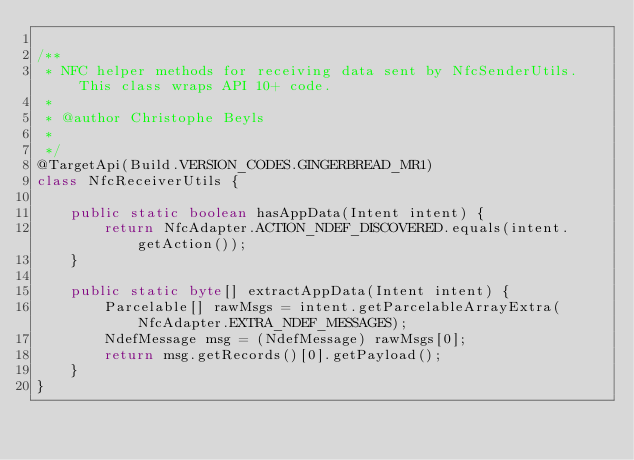<code> <loc_0><loc_0><loc_500><loc_500><_Java_>
/**
 * NFC helper methods for receiving data sent by NfcSenderUtils. This class wraps API 10+ code.
 * 
 * @author Christophe Beyls
 * 
 */
@TargetApi(Build.VERSION_CODES.GINGERBREAD_MR1)
class NfcReceiverUtils {

	public static boolean hasAppData(Intent intent) {
		return NfcAdapter.ACTION_NDEF_DISCOVERED.equals(intent.getAction());
	}

	public static byte[] extractAppData(Intent intent) {
		Parcelable[] rawMsgs = intent.getParcelableArrayExtra(NfcAdapter.EXTRA_NDEF_MESSAGES);
		NdefMessage msg = (NdefMessage) rawMsgs[0];
		return msg.getRecords()[0].getPayload();
	}
}
</code> 